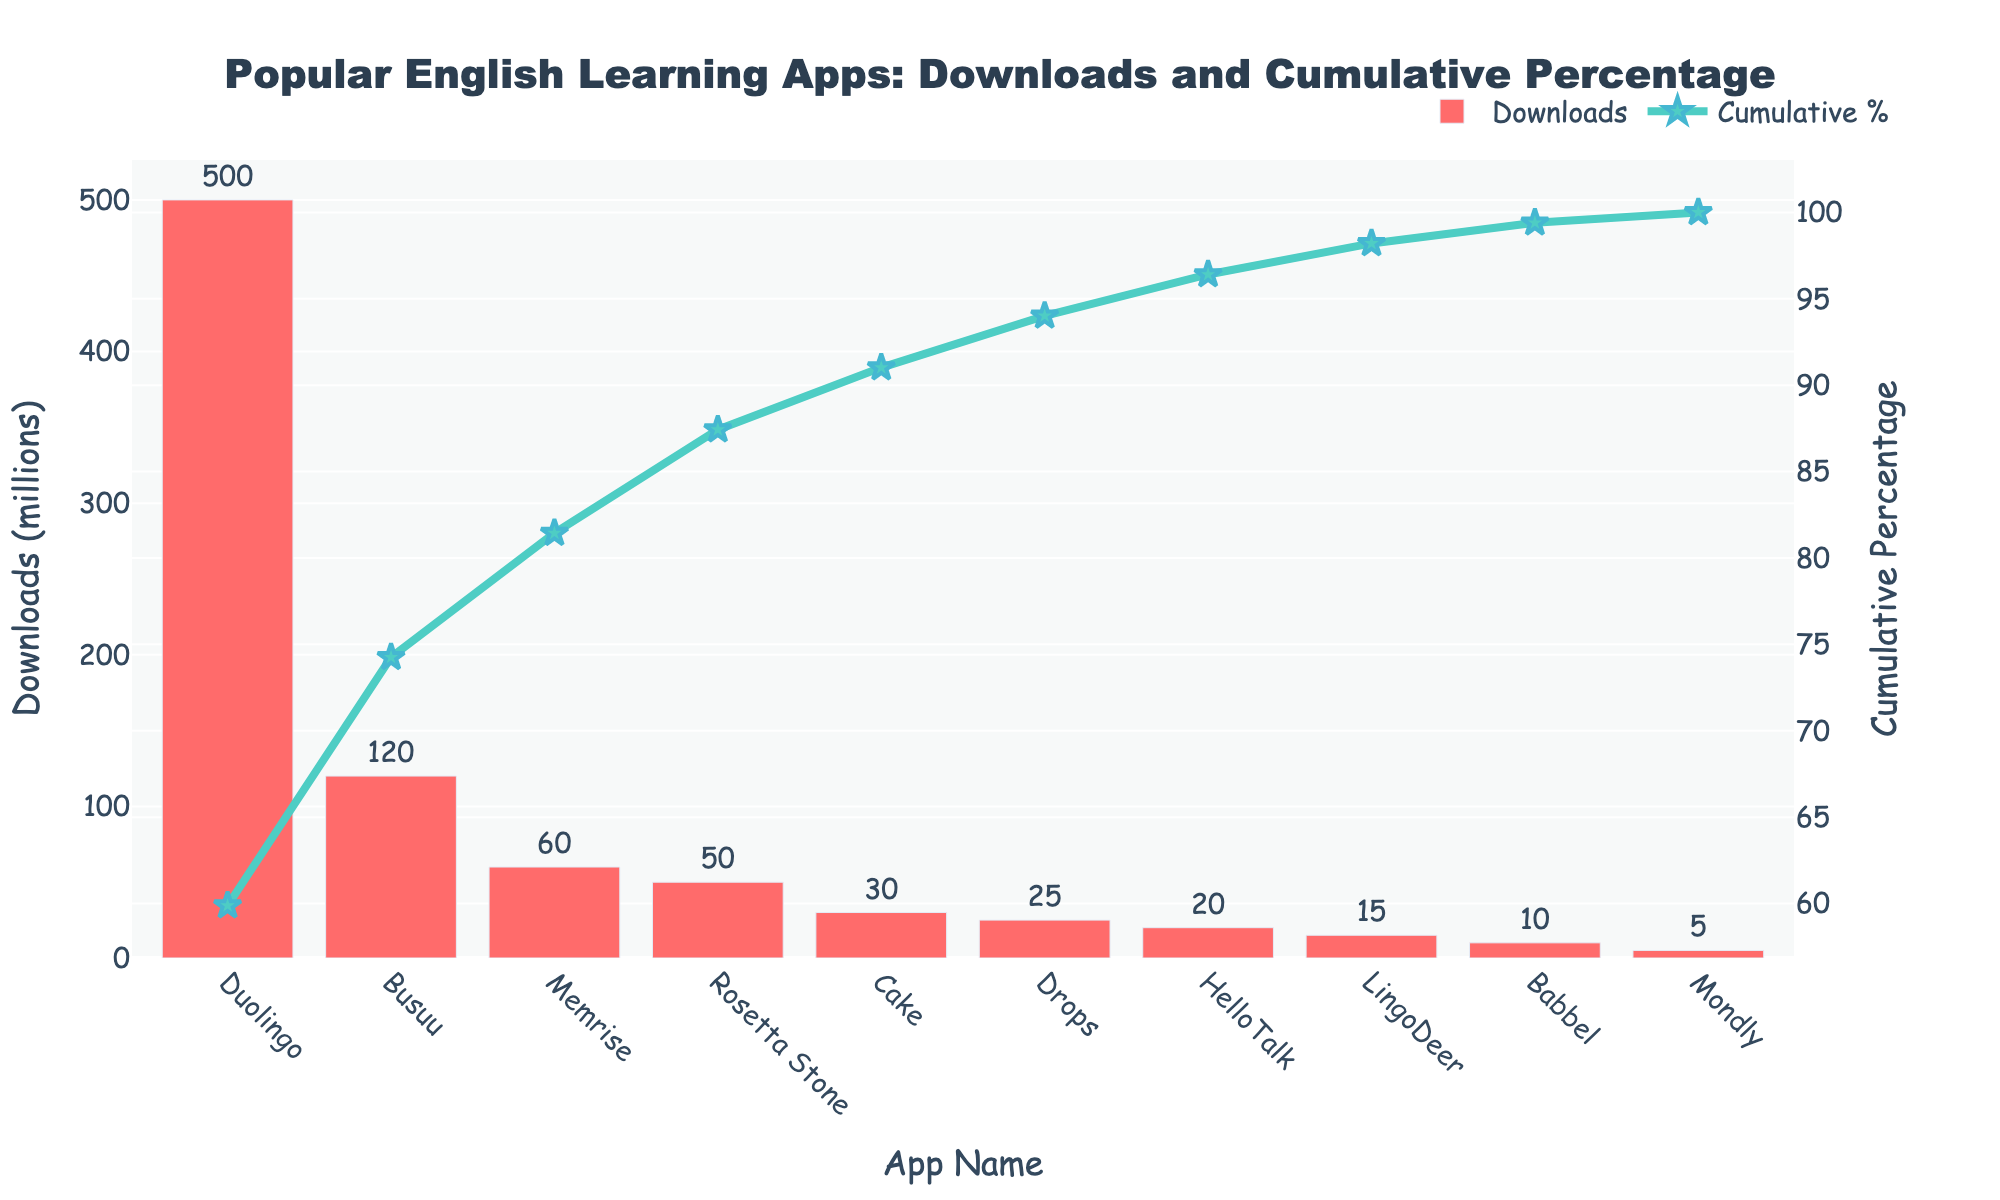What is the title of the figure? The title of the figure is displayed at the top and it provides a summary of what the figure is about.
Answer: Popular English Learning Apps: Downloads and Cumulative Percentage Which app has the highest number of downloads? The height of the bar corresponds to the Downloads (millions), and the app with the tallest bar has the highest number of downloads.
Answer: Duolingo What is the cumulative percentage for Duolingo? The line chart shows the cumulative percentage on the right y-axis. At the point corresponding to Duolingo, look at the cumulative % value.
Answer: 58.82% How many apps have more than 50 million downloads? Look at the bars to see which apps' downloads are above the 50 million threshold. Count those bars.
Answer: 4 What is the total number of downloads for the top three apps? Identify the top three apps by their download numbers, which are the tallest bars. Sum their download values. Duolingo (500), Busuu (120), Rosetta Stone (50). 500 + 120 + 50.
Answer: 670 million Which app has the lowest number of downloads? The app with the shortest bar represents the lowest downloads.
Answer: Mondly What is the total cumulative percentage at the fourth app? Trace the cumulative percentage value from the line chart above the fourth app.
Answer: 88.24% What is the cumulative % difference between Busuu and LingoDeer? Find the cumulative percentages for Busuu and LingoDeer, then calculate the difference: Busuu (73.52%), LingoDeer (91.76%). 91.76 - 73.52.
Answer: 18.24% Compare the downloads of Memrise and Cake. Which has more? Observe the height of the bars for Memrise (60 million) and Cake (30 million). The taller bar indicates more downloads.
Answer: Memrise How do the color and size of markers in the line chart help interpret the data? The color and size of markers highlight specific data points clearly and make it easy to trace the cumulative percentage across apps. They emphasize the importance of the data points by using distinct visual contrasts.
Answer: Highlight data points and emphasize cumulative percentage 